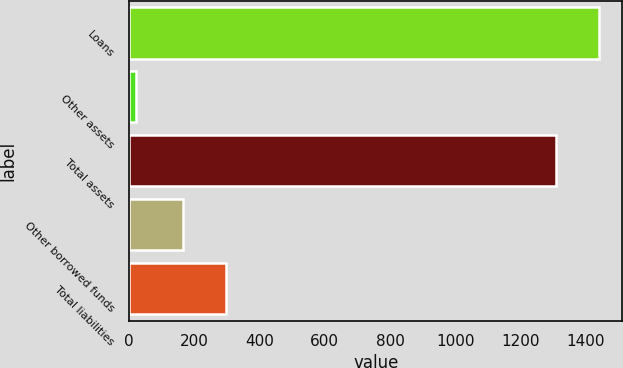Convert chart to OTSL. <chart><loc_0><loc_0><loc_500><loc_500><bar_chart><fcel>Loans<fcel>Other assets<fcel>Total assets<fcel>Other borrowed funds<fcel>Total liabilities<nl><fcel>1440.3<fcel>22<fcel>1309<fcel>166<fcel>297.3<nl></chart> 